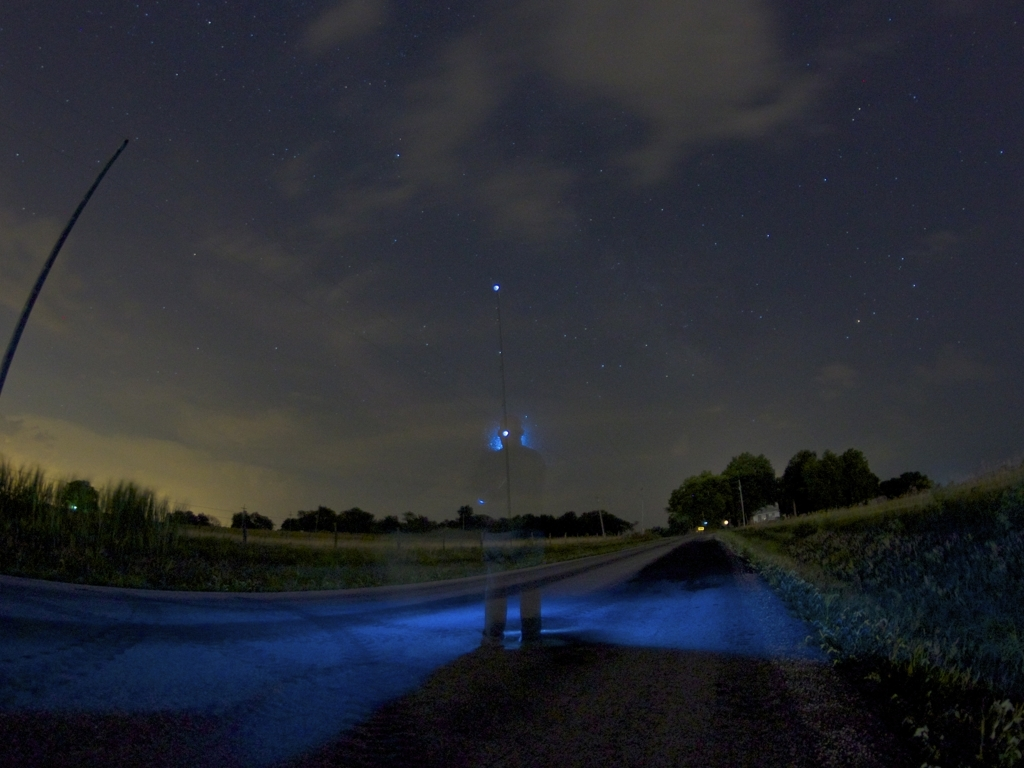What's happening in this photo? This photo captures a long exposure shot, where a stationary subject appears ghost-like due to movement, against a backdrop of stars. It's a creative technique often used in night photography to achieve dramatic effects. What can you tell me about the technique used to take this photo? The technique employed is called long exposure photography. It involves leaving the camera's shutter open for an extended period of time, which allows more light to enter and captures the motion of objects as blurs or streaks. The starry sky and the 'ghost' figure suggest a shutter speed of several seconds or more. 